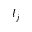Convert formula to latex. <formula><loc_0><loc_0><loc_500><loc_500>l _ { j }</formula> 